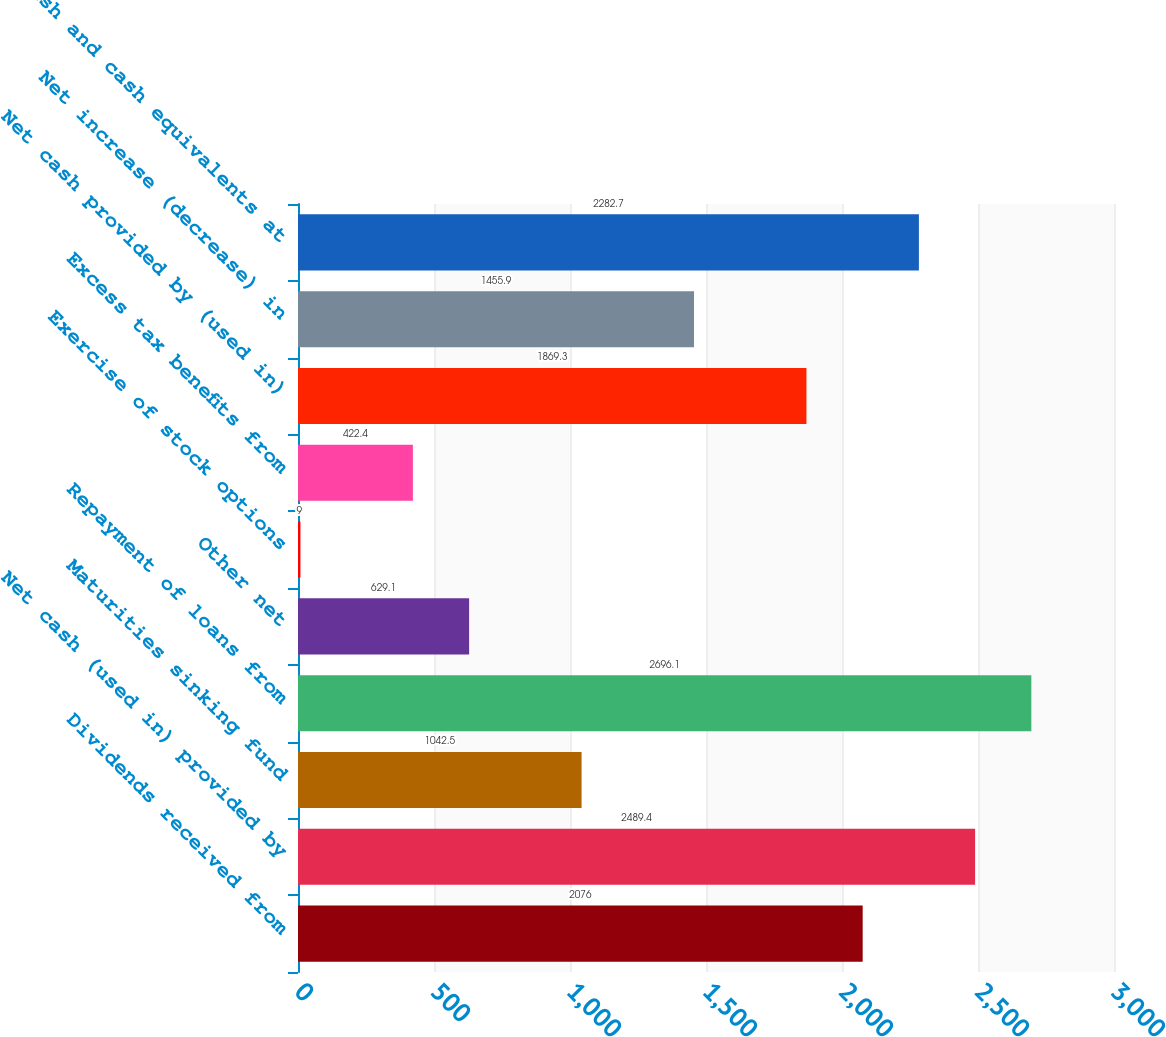Convert chart. <chart><loc_0><loc_0><loc_500><loc_500><bar_chart><fcel>Dividends received from<fcel>Net cash (used in) provided by<fcel>Maturities sinking fund<fcel>Repayment of loans from<fcel>Other net<fcel>Exercise of stock options<fcel>Excess tax benefits from<fcel>Net cash provided by (used in)<fcel>Net increase (decrease) in<fcel>Cash and cash equivalents at<nl><fcel>2076<fcel>2489.4<fcel>1042.5<fcel>2696.1<fcel>629.1<fcel>9<fcel>422.4<fcel>1869.3<fcel>1455.9<fcel>2282.7<nl></chart> 